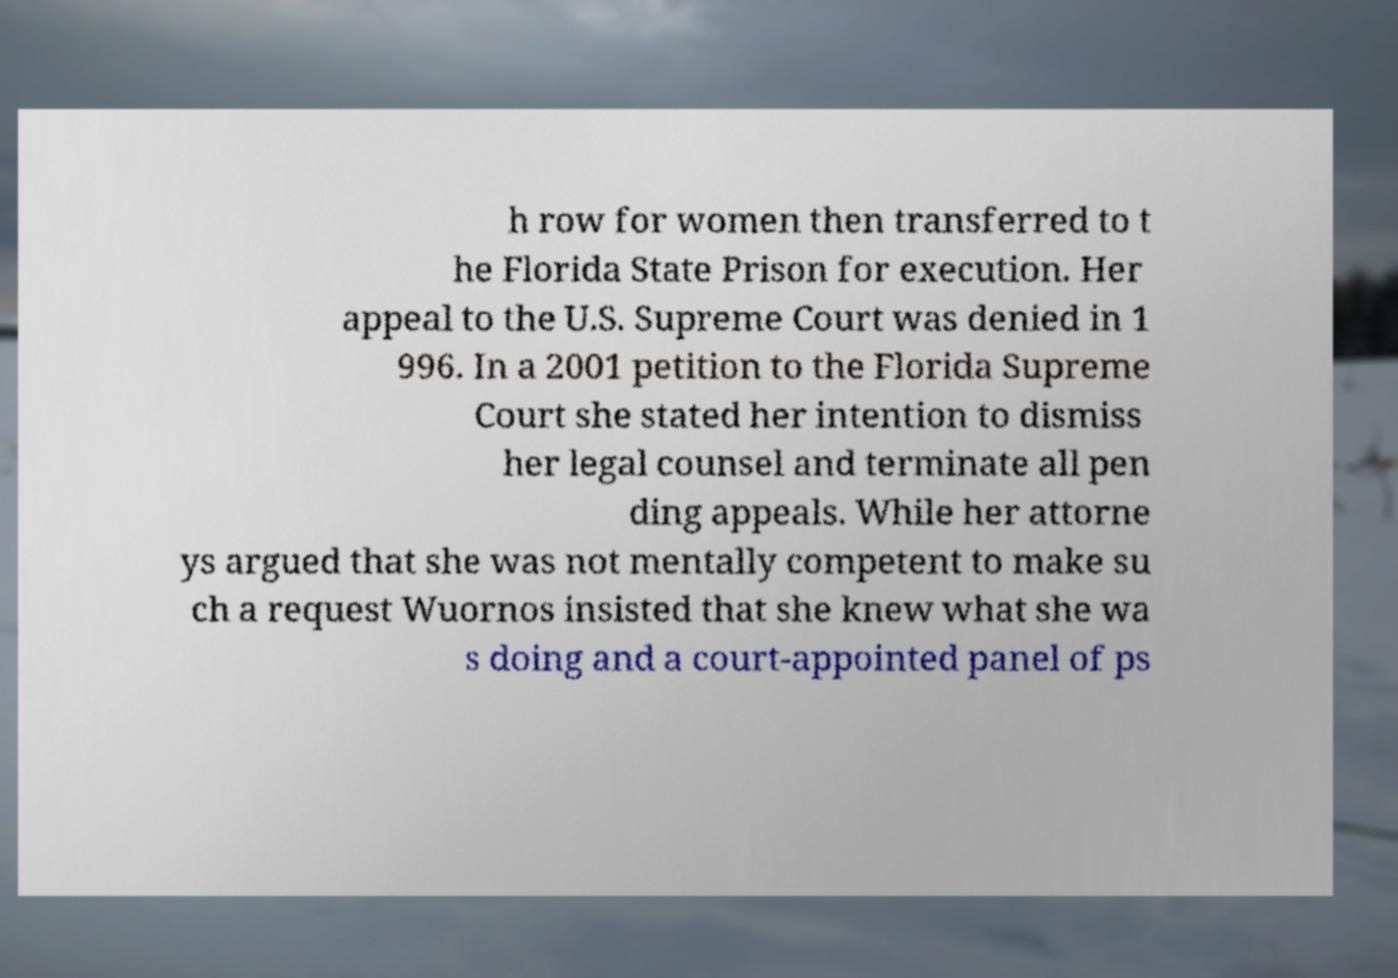Can you read and provide the text displayed in the image?This photo seems to have some interesting text. Can you extract and type it out for me? h row for women then transferred to t he Florida State Prison for execution. Her appeal to the U.S. Supreme Court was denied in 1 996. In a 2001 petition to the Florida Supreme Court she stated her intention to dismiss her legal counsel and terminate all pen ding appeals. While her attorne ys argued that she was not mentally competent to make su ch a request Wuornos insisted that she knew what she wa s doing and a court-appointed panel of ps 